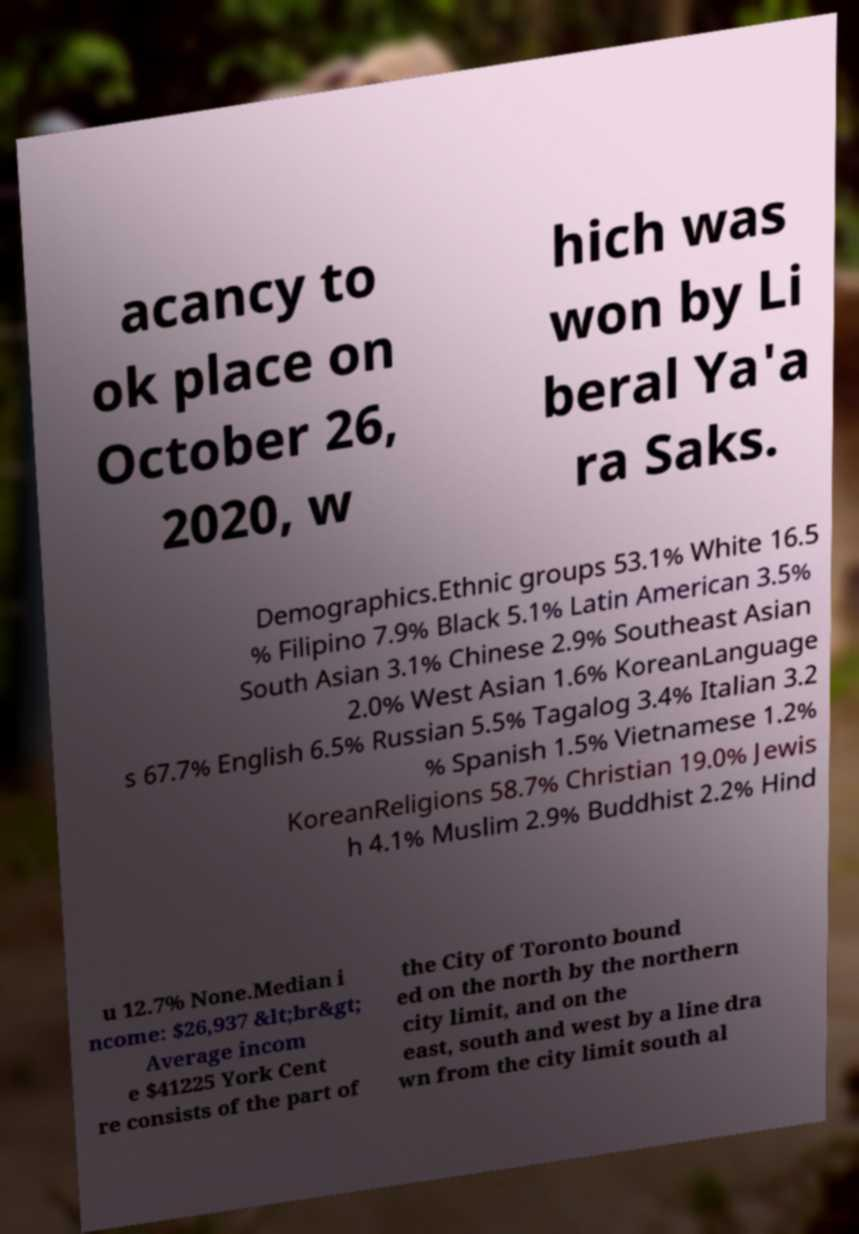Can you read and provide the text displayed in the image?This photo seems to have some interesting text. Can you extract and type it out for me? acancy to ok place on October 26, 2020, w hich was won by Li beral Ya'a ra Saks. Demographics.Ethnic groups 53.1% White 16.5 % Filipino 7.9% Black 5.1% Latin American 3.5% South Asian 3.1% Chinese 2.9% Southeast Asian 2.0% West Asian 1.6% KoreanLanguage s 67.7% English 6.5% Russian 5.5% Tagalog 3.4% Italian 3.2 % Spanish 1.5% Vietnamese 1.2% KoreanReligions 58.7% Christian 19.0% Jewis h 4.1% Muslim 2.9% Buddhist 2.2% Hind u 12.7% None.Median i ncome: $26,937 &lt;br&gt; Average incom e $41225 York Cent re consists of the part of the City of Toronto bound ed on the north by the northern city limit, and on the east, south and west by a line dra wn from the city limit south al 